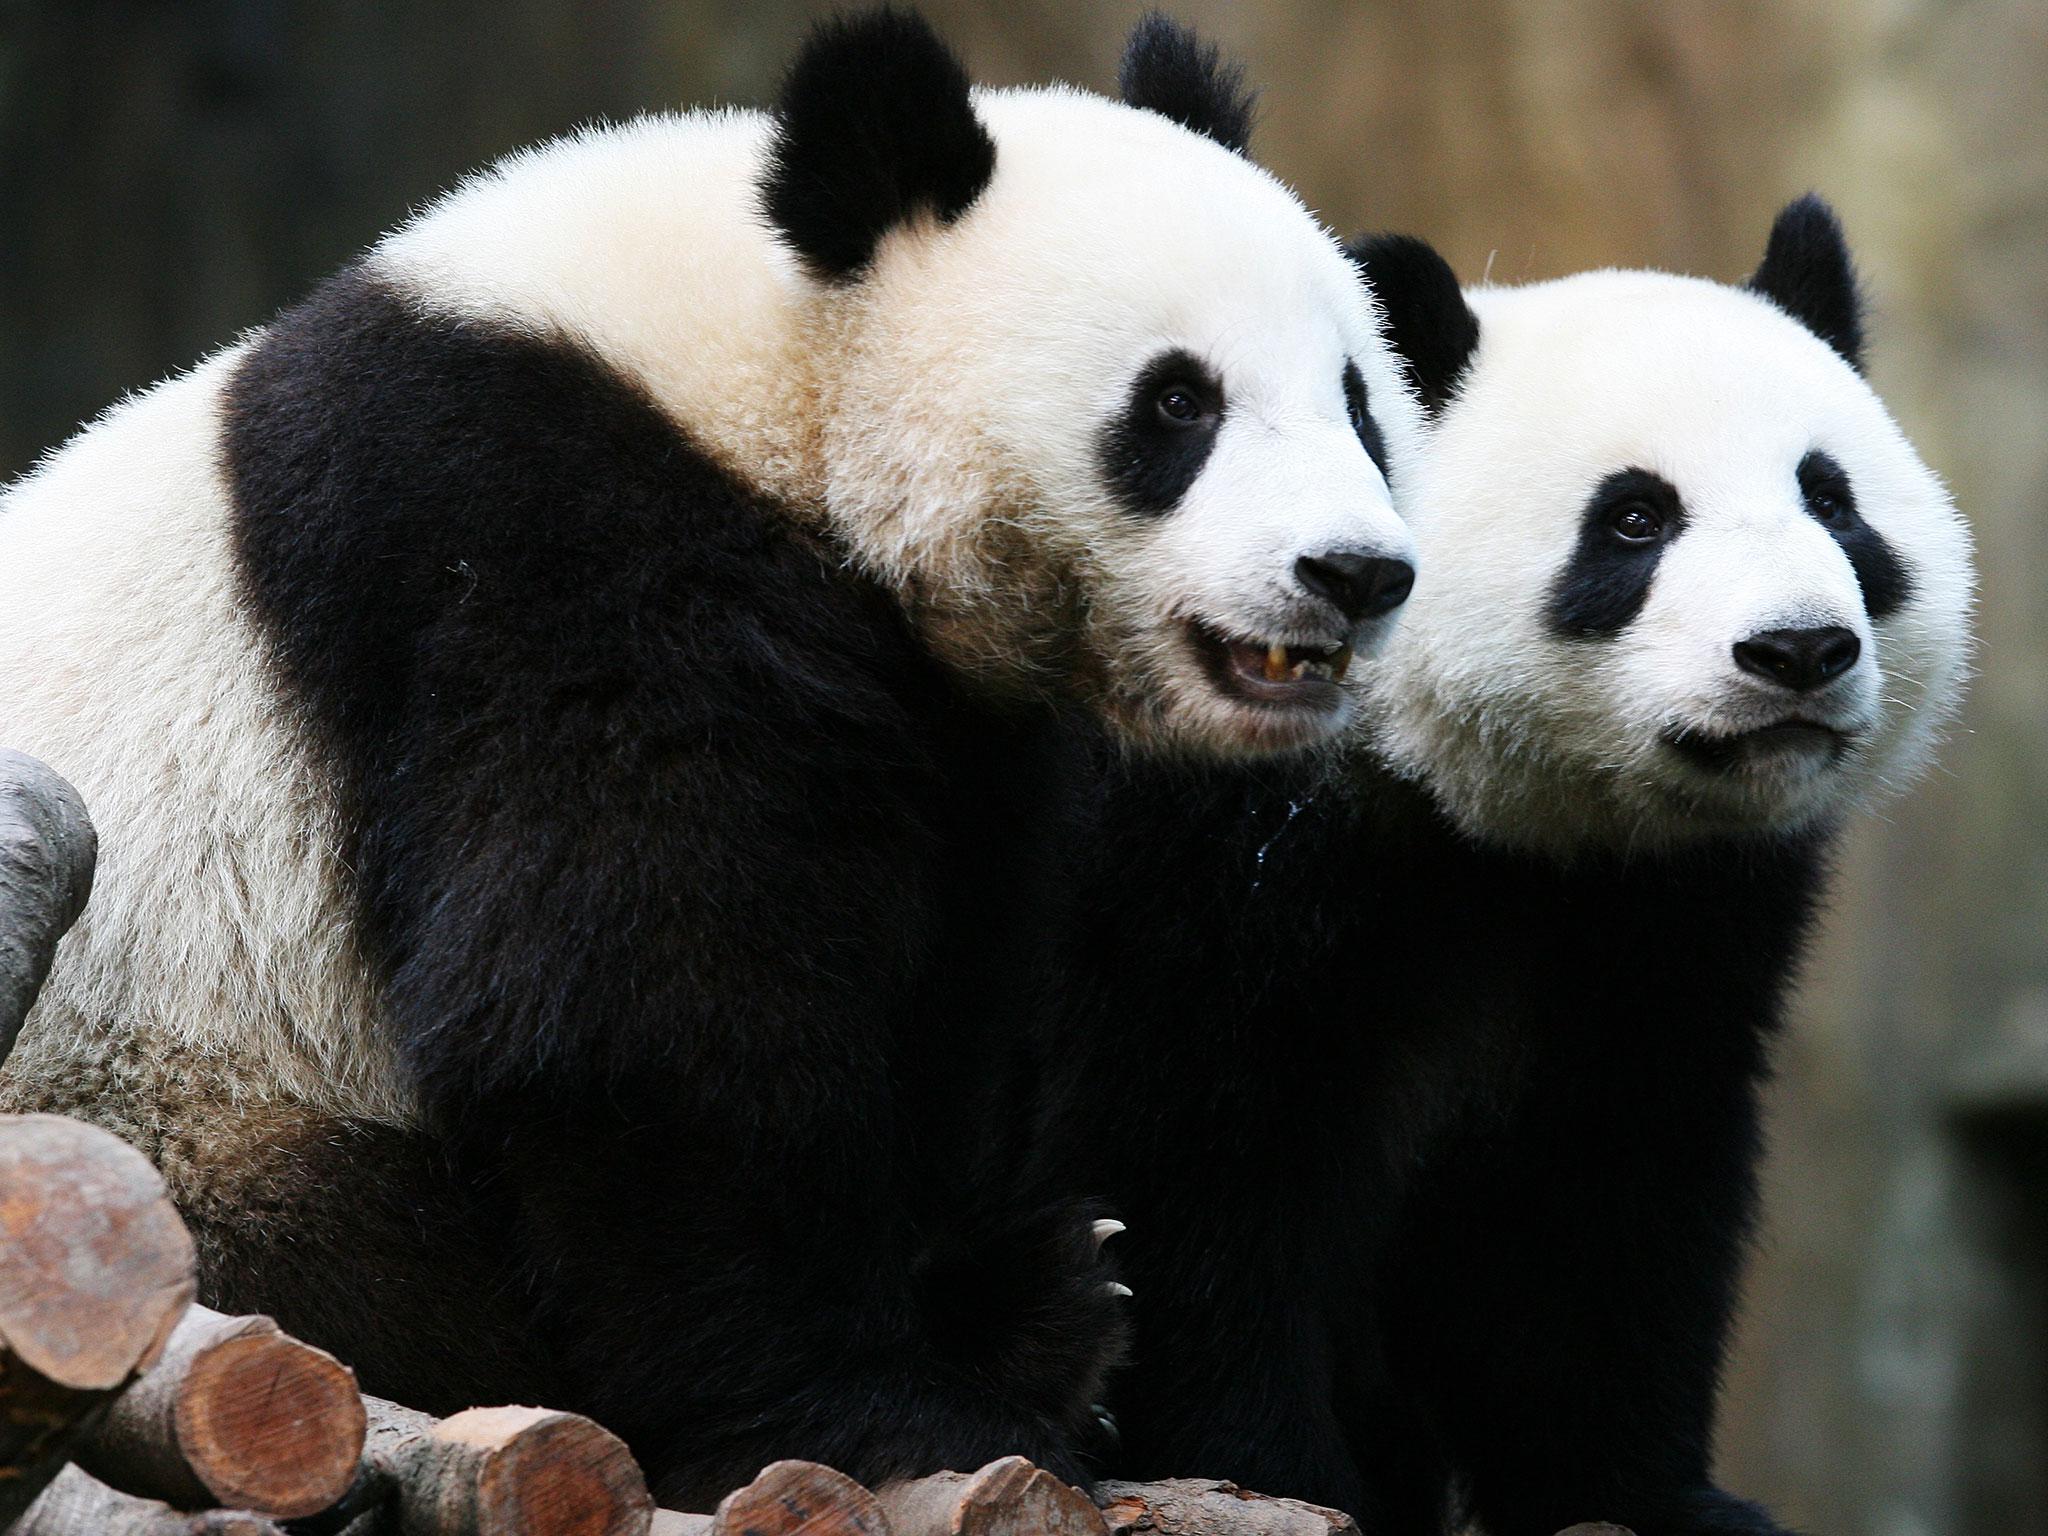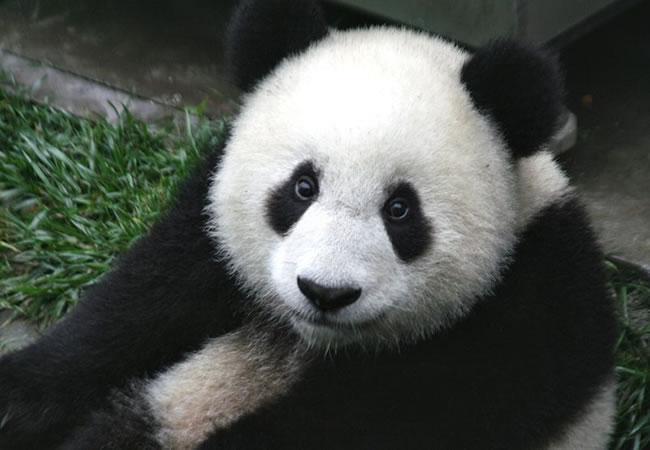The first image is the image on the left, the second image is the image on the right. For the images shown, is this caption "An image shows one camera-facing panda in a grassy area, standing with all four paws on a surface." true? Answer yes or no. No. 